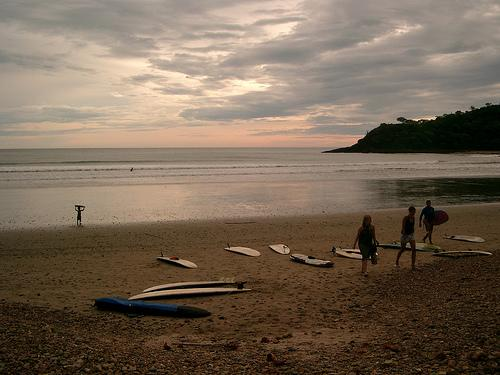What emotions could be associated with the image? The image evokes feelings of relaxation and tranquility, with people enjoying their leisure time on the beach, indulging in surfing and breathing in the refreshing ocean air. Identify any noticeable interactions between people and objects in the photo. People are carrying surfboards, walking with them in hand or under their arm, while others walk towards or away from the water, some accompanied by partners or friends. Describe the landscape features beyond the main beach area in the image. The background features an elevated area with trees and hills, adding depth to the overall scenery of the beach setting. How many people can be seen in the ocean? There is one person in the ocean, who appears to be surfing. Analyze the different textures and elements present in the image. The image is rich with textures and elements such as the wet sand, crashing waves, rocks, and gravel, the soft clouds in the sky, and the footprints left behind on the sandy beach. What is the condition of the water in the beach scene? The water appears to be dark and calm, gently lapping at the shoreline near the wet sand. Estimate the number of people shown in the image and describe their activities. There are around 10 people in the image, engaging in various activities such as surfing, walking on the beach with or without surfboards, and standing in the water. How many surfboards can be seen on the beach, and provide a brief description of their appearance? There are several surfboards scattered across the beach, with varying colors and designs, such as a blue surfboard lying on the ground, a white surfboard, and a black and white surfboard with a decorative pattern. Evaluate the quality of the image in terms of composition and subjects captured. The image is well-composed, capturing various elements such as people, surfboards, the ocean, and the sky, which together create a picturesque scene of a beach at sunset. Describe the atmosphere of the beach at sunset. The beach has a serene and calming atmosphere with the sky painted in soft pink hues and light red as the sun sets, casting a warm glow on the ocean waves. 